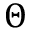<formula> <loc_0><loc_0><loc_500><loc_500>\Theta</formula> 